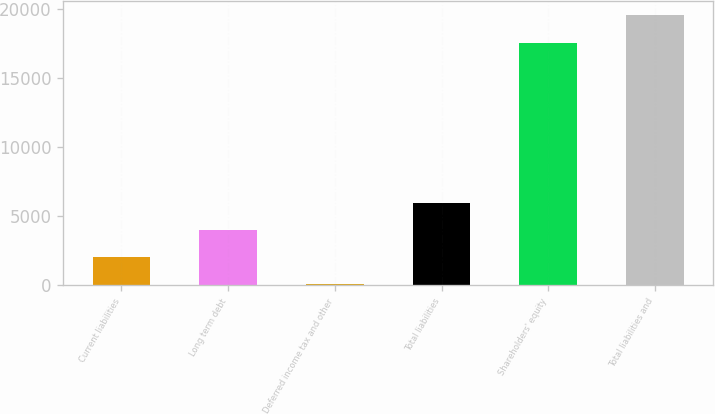<chart> <loc_0><loc_0><loc_500><loc_500><bar_chart><fcel>Current liabilities<fcel>Long term debt<fcel>Deferred income tax and other<fcel>Total liabilities<fcel>Shareholders' equity<fcel>Total liabilities and<nl><fcel>2051<fcel>4001<fcel>101<fcel>5951<fcel>17561<fcel>19601<nl></chart> 